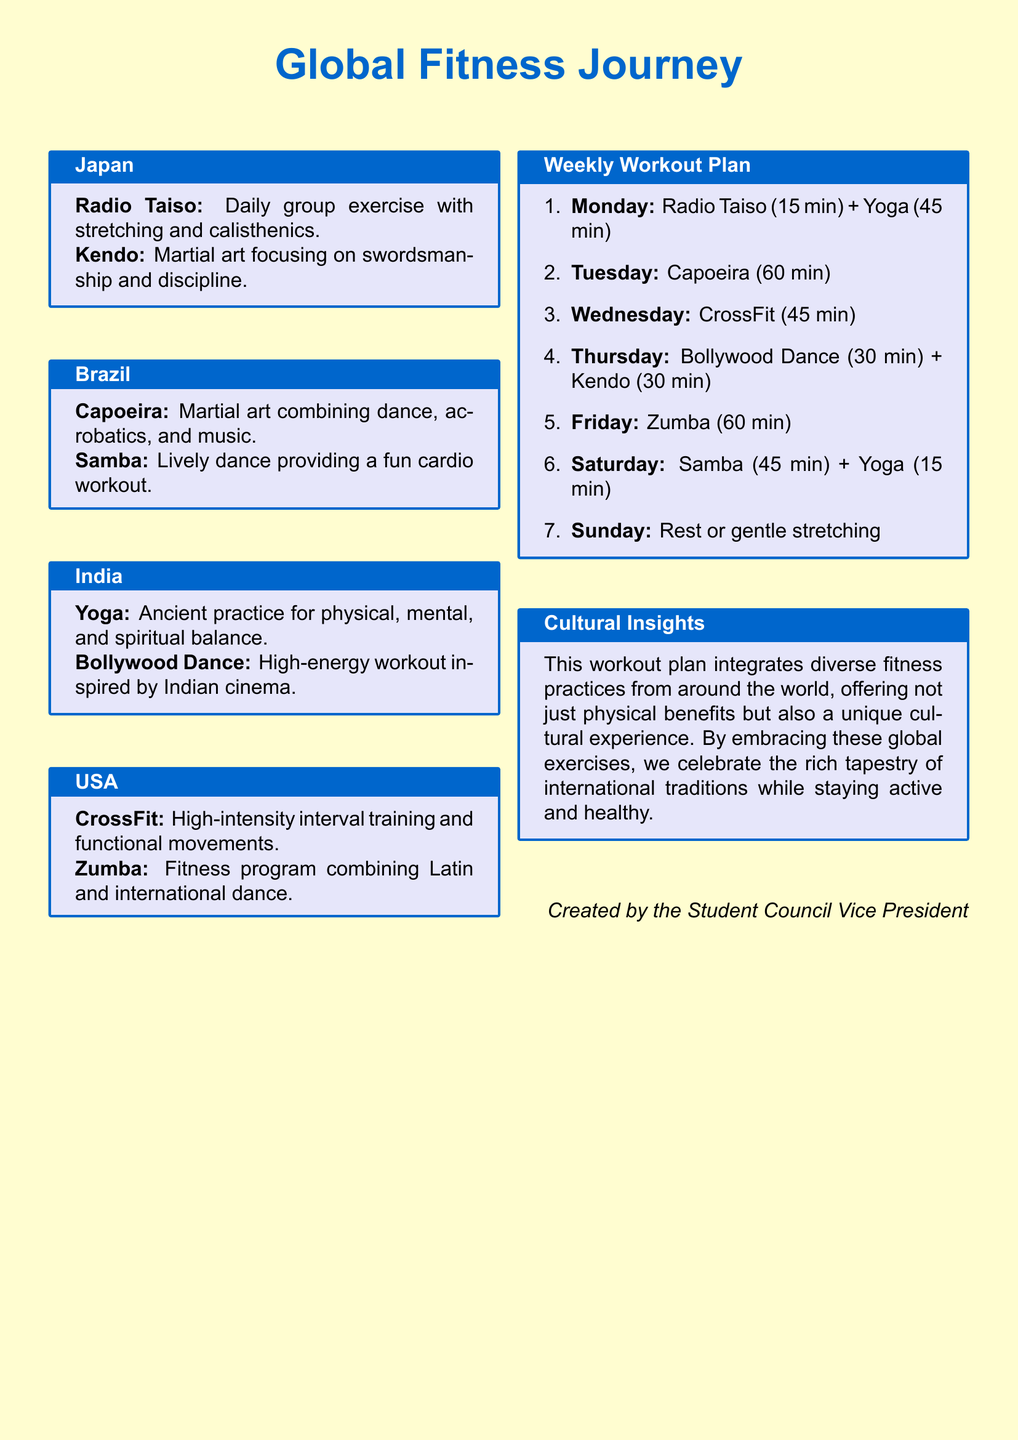What are the two workouts listed for Japan? The document lists Radio Taiso and Kendo as the two workouts for Japan.
Answer: Radio Taiso, Kendo Which country features Capoeira? The document specifies Brazil as the country featuring Capoeira.
Answer: Brazil What is the duration of Yoga on Monday? The document indicates that Yoga on Monday lasts for 45 minutes.
Answer: 45 min How many fitness activities are included in the Saturday workout? The Saturday workout includes two activities: Samba and Yoga.
Answer: 2 What type of dance is associated with Bollywood in India? The document refers to Bollywood Dance as a high-energy workout inspired by Indian cinema.
Answer: Bollywood Dance Which workout is scheduled for Wednesday? The document states that CrossFit is scheduled for Wednesday.
Answer: CrossFit What is the total time allocated for the Sunday workout? The document mentions Rest or gentle stretching for Sunday, indicating no specific time allocated.
Answer: N/A What do the cultural insights highlight about the workout plan? The cultural insights emphasize the integration of diverse fitness practices and cultural experiences in the workout plan.
Answer: Cultural experience How long is the Capoeira session on Tuesday? The document specifies that the Capoeira session lasts for 60 minutes.
Answer: 60 min 